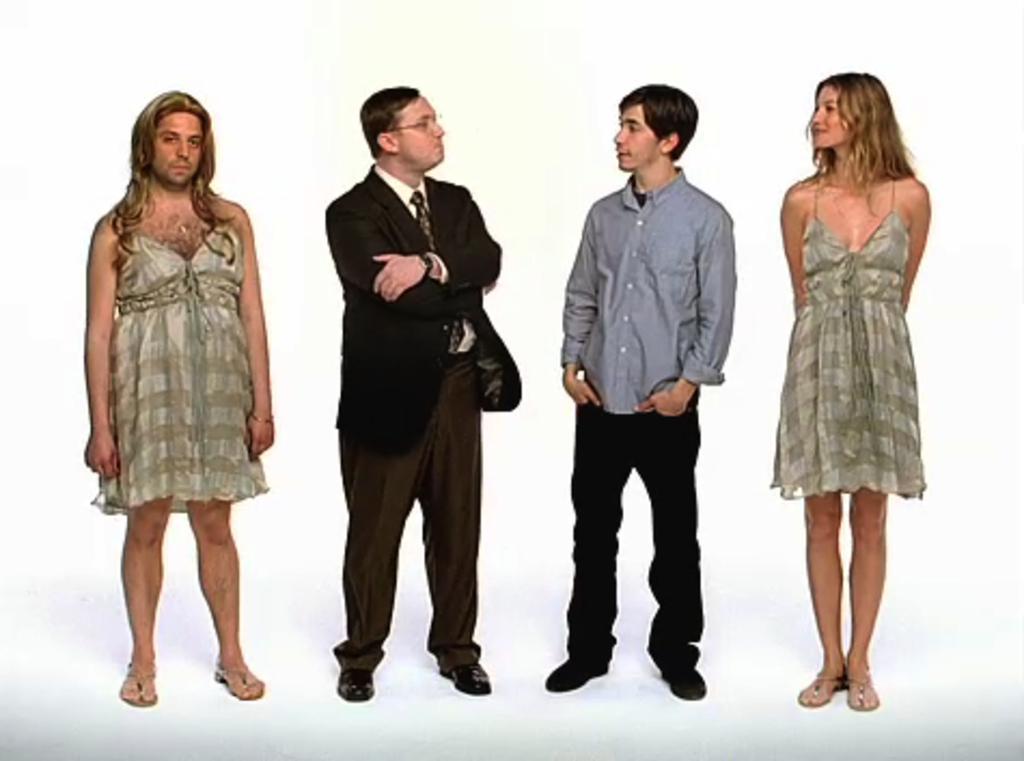Could you give a brief overview of what you see in this image? In this image we can see people standing. 